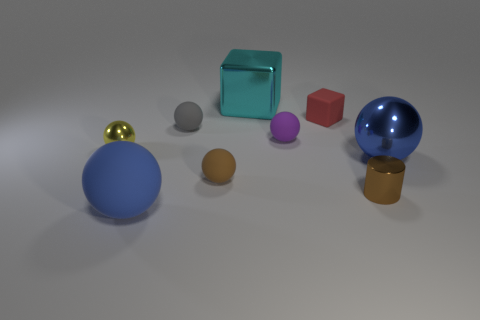Subtract all tiny balls. How many balls are left? 2 Subtract all red blocks. How many blocks are left? 1 Subtract all cylinders. How many objects are left? 8 Subtract all yellow spheres. How many red blocks are left? 1 Subtract all brown balls. Subtract all small cylinders. How many objects are left? 7 Add 5 yellow objects. How many yellow objects are left? 6 Add 4 small matte balls. How many small matte balls exist? 7 Subtract 0 red spheres. How many objects are left? 9 Subtract 1 cylinders. How many cylinders are left? 0 Subtract all red cylinders. Subtract all yellow balls. How many cylinders are left? 1 